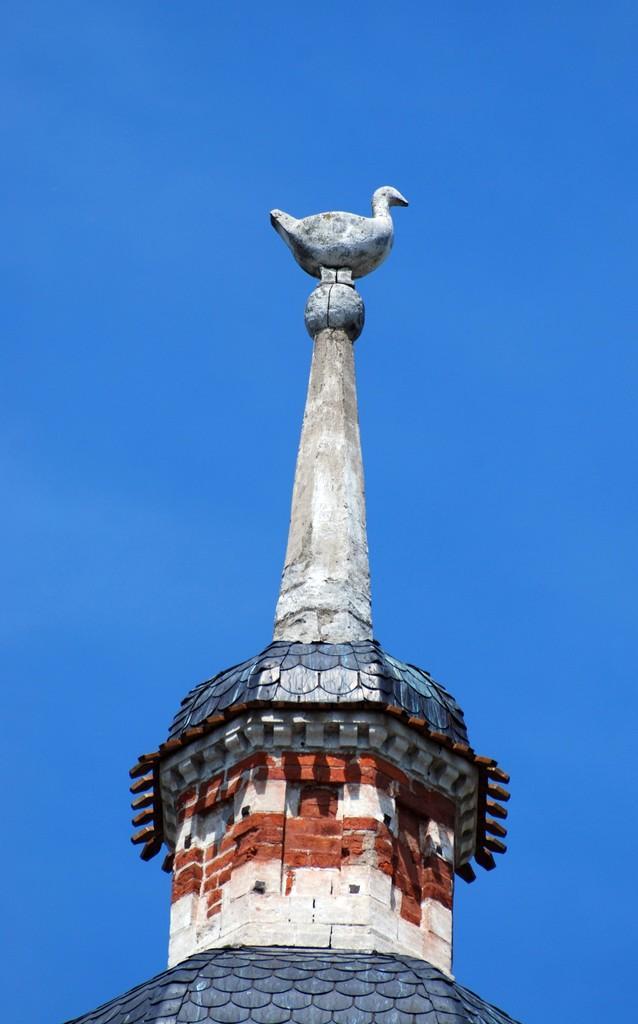Please provide a concise description of this image. In this picture we can see a building with a statue of a bird on it and in the background we can see the sky. 